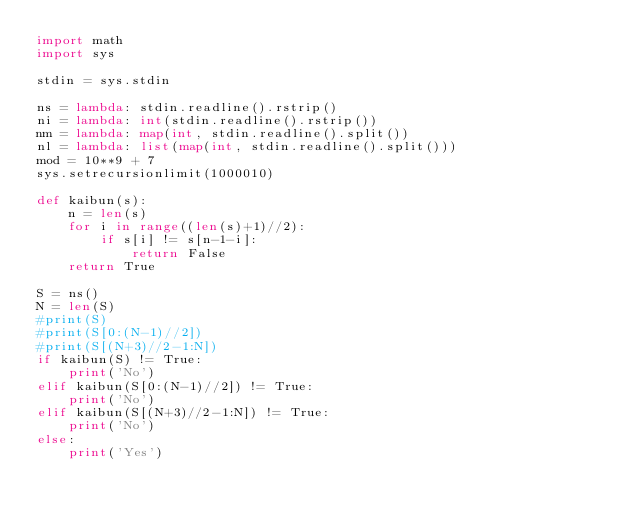Convert code to text. <code><loc_0><loc_0><loc_500><loc_500><_Python_>import math
import sys

stdin = sys.stdin

ns = lambda: stdin.readline().rstrip()
ni = lambda: int(stdin.readline().rstrip())
nm = lambda: map(int, stdin.readline().split())
nl = lambda: list(map(int, stdin.readline().split()))
mod = 10**9 + 7 
sys.setrecursionlimit(1000010)

def kaibun(s):
    n = len(s)
    for i in range((len(s)+1)//2):
        if s[i] != s[n-1-i]:
            return False
    return True

S = ns()
N = len(S)
#print(S)
#print(S[0:(N-1)//2])
#print(S[(N+3)//2-1:N])
if kaibun(S) != True:
    print('No')
elif kaibun(S[0:(N-1)//2]) != True:
    print('No')
elif kaibun(S[(N+3)//2-1:N]) != True:
    print('No')
else:
    print('Yes')
</code> 